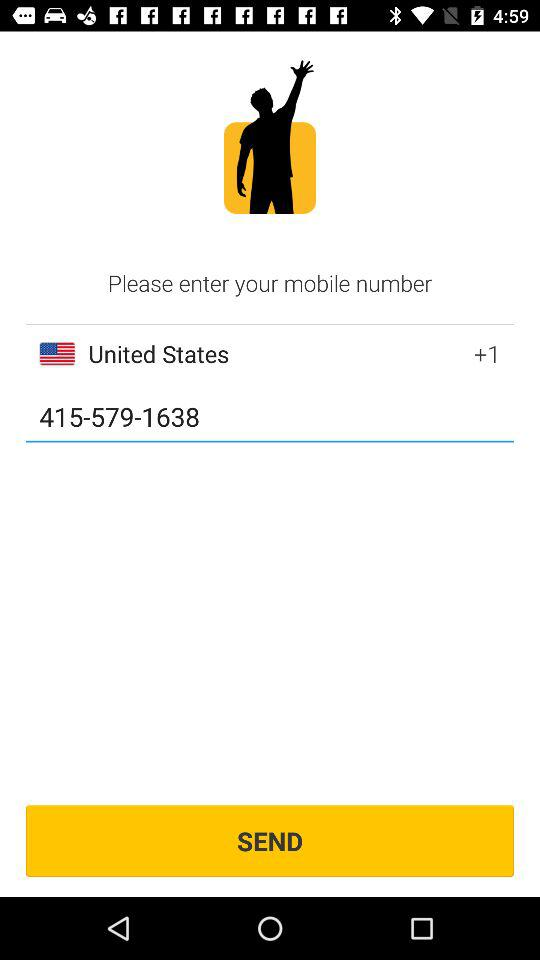What is the contact number? The contact number is 415-579-1638. 